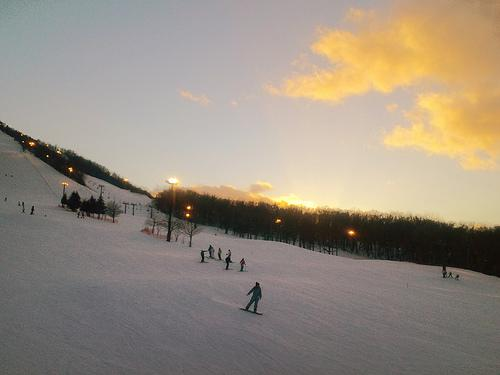Question: what time it is?
Choices:
A. Dusk.
B. Evening.
C. Sunset.
D. Night.
Answer with the letter. Answer: C Question: why people are standing on snow?
Choices:
A. To go skiing.
B. To play snowboarding.
C. To make an igloo.
D. To go sledding.
Answer with the letter. Answer: B Question: who are playing snow boarding?
Choices:
A. Adults.
B. People.
C. Kids.
D. Teenagers.
Answer with the letter. Answer: B Question: what is the color of the sky?
Choices:
A. Red.
B. Orange.
C. Blue and yellow.
D. Purple.
Answer with the letter. Answer: C Question: what season it is?
Choices:
A. Summer.
B. Spring.
C. Autumn.
D. Winter.
Answer with the letter. Answer: D 